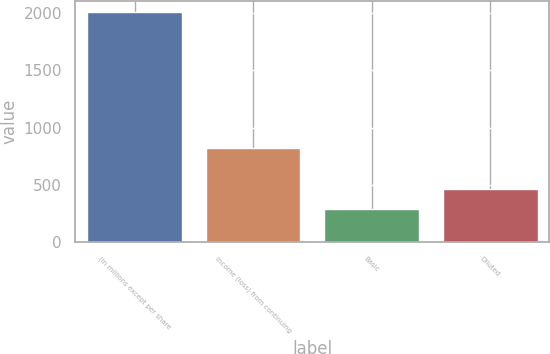Convert chart to OTSL. <chart><loc_0><loc_0><loc_500><loc_500><bar_chart><fcel>(In millions except per share<fcel>Income (loss) from continuing<fcel>Basic<fcel>Diluted<nl><fcel>2004<fcel>817.9<fcel>290<fcel>461.4<nl></chart> 